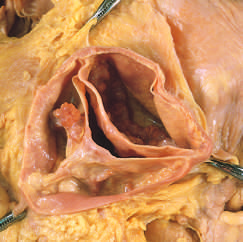what has a partial fusion at its center?
Answer the question using a single word or phrase. A cusp 